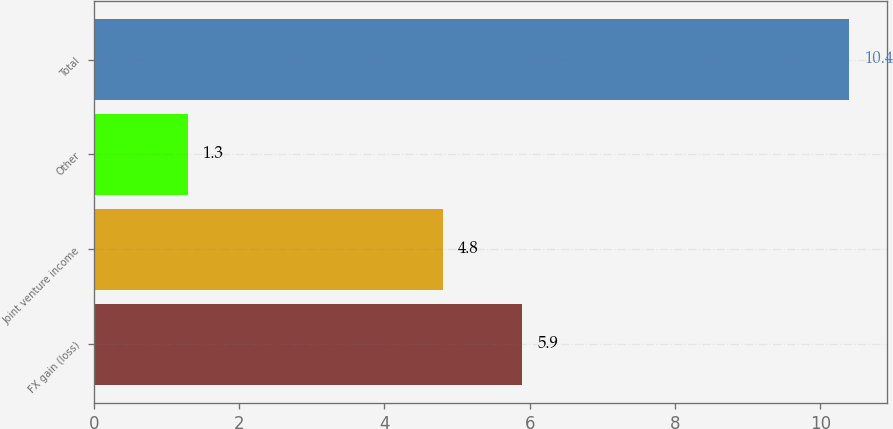Convert chart to OTSL. <chart><loc_0><loc_0><loc_500><loc_500><bar_chart><fcel>FX gain (loss)<fcel>Joint venture income<fcel>Other<fcel>Total<nl><fcel>5.9<fcel>4.8<fcel>1.3<fcel>10.4<nl></chart> 